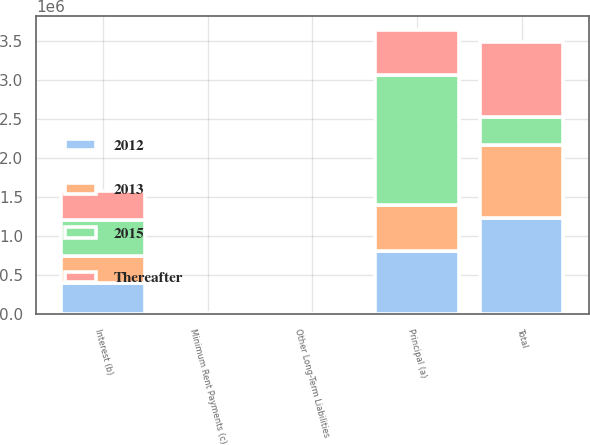<chart> <loc_0><loc_0><loc_500><loc_500><stacked_bar_chart><ecel><fcel>Principal (a)<fcel>Interest (b)<fcel>Minimum Rent Payments (c)<fcel>Other Long-Term Liabilities<fcel>Total<nl><fcel>2015<fcel>1.66599e+06<fcel>460045<fcel>5478<fcel>1457<fcel>367642<nl><fcel>2012<fcel>816309<fcel>407793<fcel>4285<fcel>1770<fcel>1.23016e+06<nl><fcel>Thereafter<fcel>578987<fcel>367642<fcel>4431<fcel>1485<fcel>952545<nl><fcel>2013<fcel>584617<fcel>344599<fcel>4736<fcel>1677<fcel>935629<nl></chart> 